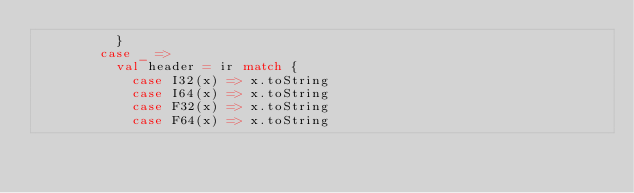<code> <loc_0><loc_0><loc_500><loc_500><_Scala_>          }
        case _ =>
          val header = ir match {
            case I32(x) => x.toString
            case I64(x) => x.toString
            case F32(x) => x.toString
            case F64(x) => x.toString</code> 